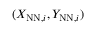<formula> <loc_0><loc_0><loc_500><loc_500>( X _ { N N , i } , Y _ { N N , i } )</formula> 